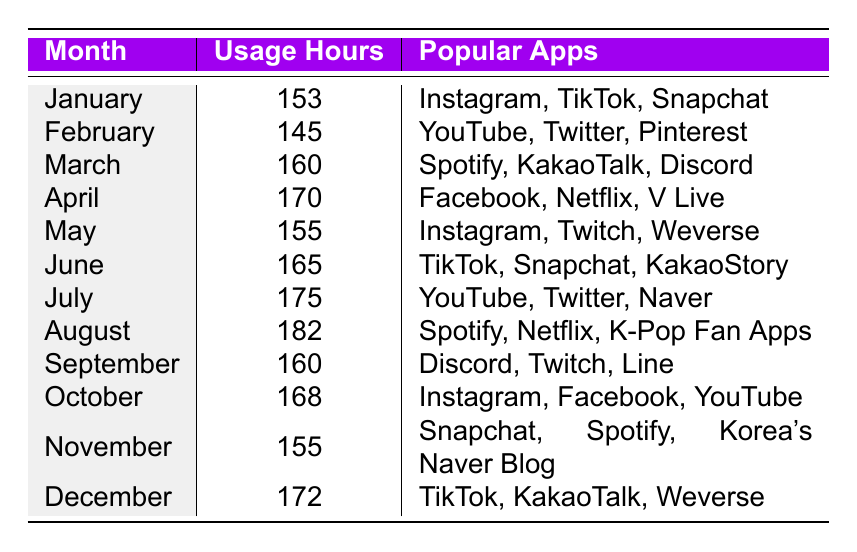What's the month with the highest smartphone usage hours? Looking through the usage hours for each month, August has the highest recorded usage at 182 hours.
Answer: August What's the smartphone usage in April? The usage hours for April are explicitly stated in the table as 170 hours.
Answer: 170 Which month showed a decrease in smartphone usage hours compared to the previous month? Comparing month-to-month, February shows a decrease (145 hours) from January (153 hours).
Answer: February What are the popular apps used in July? The table directly lists the popular apps for July as YouTube, Twitter, and Naver.
Answer: YouTube, Twitter, Naver What is the total smartphone usage hours from January to March? Adding the individual hours from January (153), February (145), and March (160) gives a total of 153 + 145 + 160 = 458.
Answer: 458 Was the smartphone usage in December higher than in November? December's usage is recorded as 172 hours, which is higher than November's 155 hours, so the answer is yes.
Answer: Yes What is the average smartphone usage for the last six months of the year? Adding the usage hours from July (175), August (182), September (160), October (168), November (155), and December (172) gives a sum of 175 + 182 + 160 + 168 + 155 + 172 = 1012. Dividing by 6 months gives 1012/6 = 168.67, rounded to 169.
Answer: 169 Which month had usage hours of exactly 155? The table shows that both May and November have 155 hours recorded.
Answer: May, November What are the popular apps in the month with the second highest smartphone usage hours? The second highest usage is in July (175 hours), and the popular apps listed for that month are YouTube, Twitter, and Naver.
Answer: YouTube, Twitter, Naver 